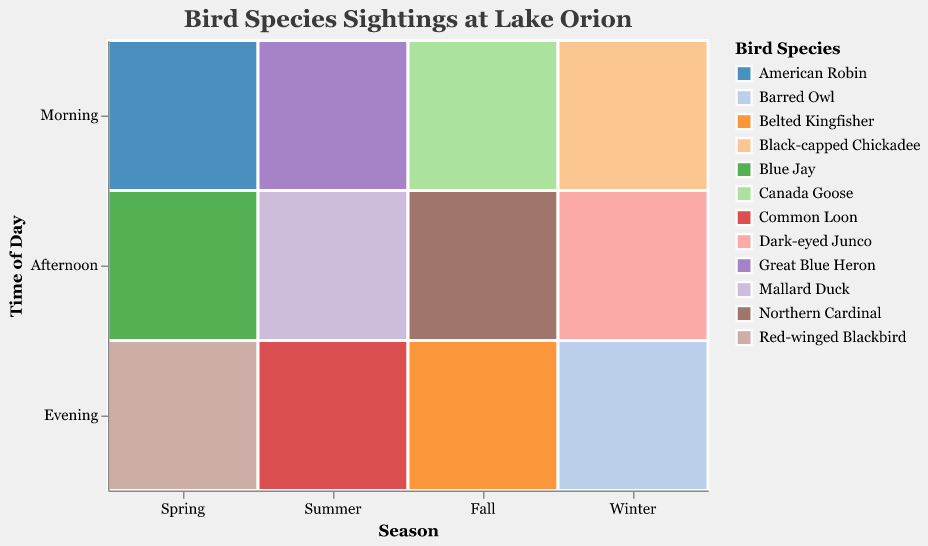Which season has the highest bird species sightings in the morning? Observe the data values for each season during the morning time. Spring morning has 42 sightings, Summer morning has 15, Fall morning has 60, and Winter morning has 30. The highest count is in Fall with 60 sightings.
Answer: Fall What is the most common bird species seen during Summer afternoons? Look at Summer and the Afternoon category. The species listed is Mallard Duck with a count of 50.
Answer: Mallard Duck Compare the total number of bird sightings in the morning and in the evening during Fall. Which time of day has more sightings? Fall Morning has 60 sightings (Canada Goose). Fall Evening has 12 sightings (Belted Kingfisher). By comparing them, 60 is greater than 12.
Answer: Morning Which season and time of day see the least number of bird species sightings? Check all the counts for all seasons and times of day. The least number is 5, observed in Winter Evening with the Barred Owl.
Answer: Winter Evening What bird species is sighted during the morning in Winter and how many times is it seen? Refer to Winter and Morning category. The species listed is Black-capped Chickadee and the count is 30.
Answer: Black-capped Chickadee, 30 Compare the sightings of Red-winged Blackbird in Spring evenings with Dark-eyed Junco in Winter afternoons. Which has more sightings? Spring Evening shows 35 Red-winged Blackbird sightings, Winter Afternoon shows 25 Dark-eyed Junco sightings. 35 is more than 25.
Answer: Red-winged Blackbird in Spring evenings How many different bird species were observed in each season? Spring has 3 species (American Robin, Blue Jay, Red-winged Blackbird). Summer has 3 species (Great Blue Heron, Mallard Duck, Common Loon). Fall has 3 species (Canada Goose, Northern Cardinal, Belted Kingfisher). Winter has 3 species (Black-capped Chickadee, Dark-eyed Junco, Barred Owl). Each season has 3 species.
Answer: 3 species per season In which season and at what time of day is the Great Blue Heron observed, and how many times? Identify the season and time for the Great Blue Heron from the table. It is Summer Morning with 15 sightings.
Answer: Summer Morning, 15 What is the most frequently seen bird species across all the seasons and times of day? Identify the highest count in the data. Canada Goose in Fall Morning has the highest count of 60.
Answer: Canada Goose 